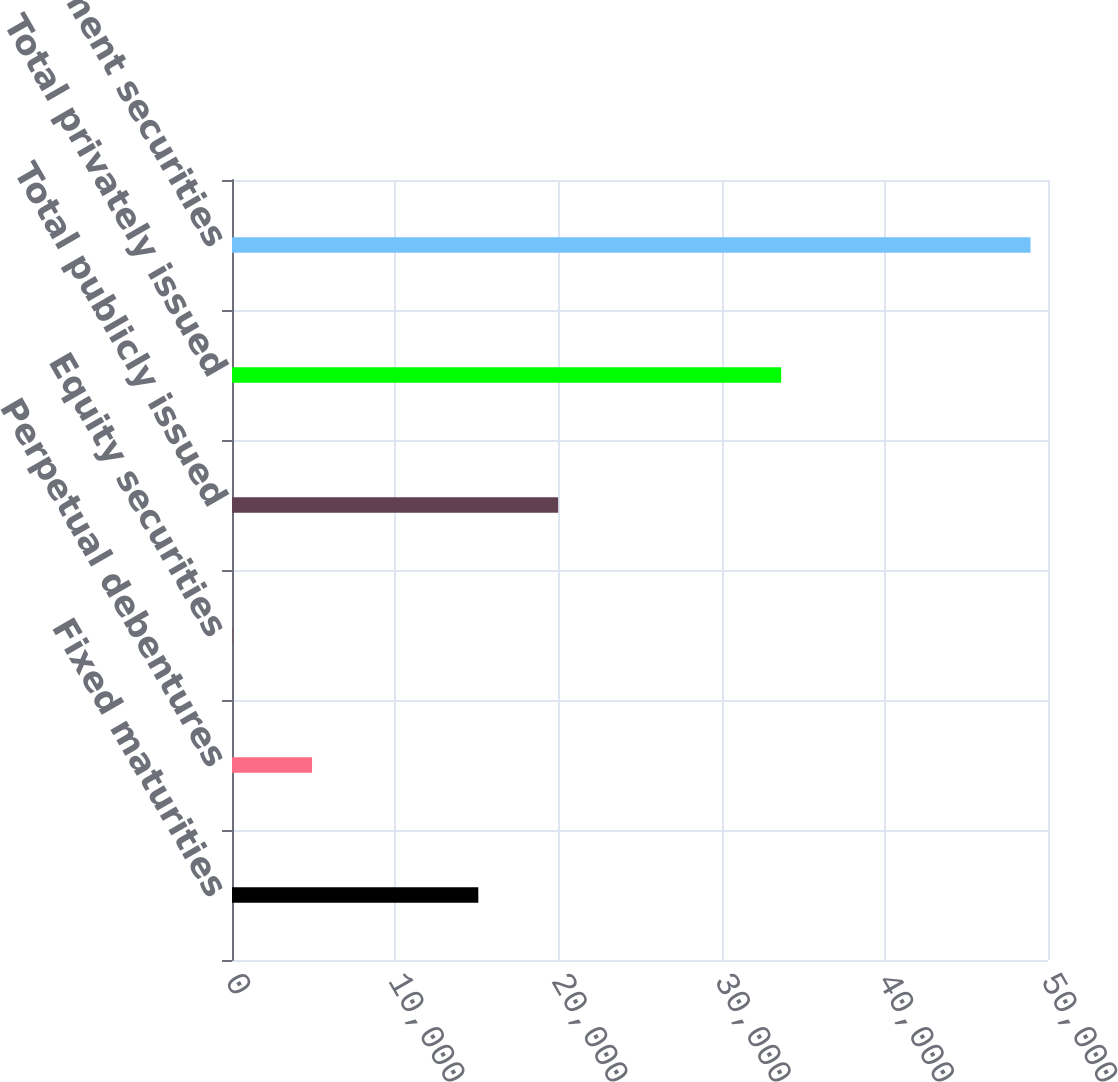Convert chart to OTSL. <chart><loc_0><loc_0><loc_500><loc_500><bar_chart><fcel>Fixed maturities<fcel>Perpetual debentures<fcel>Equity securities<fcel>Total publicly issued<fcel>Total privately issued<fcel>Total investment securities<nl><fcel>15092<fcel>4904.6<fcel>13<fcel>19983.6<fcel>33651<fcel>48929<nl></chart> 